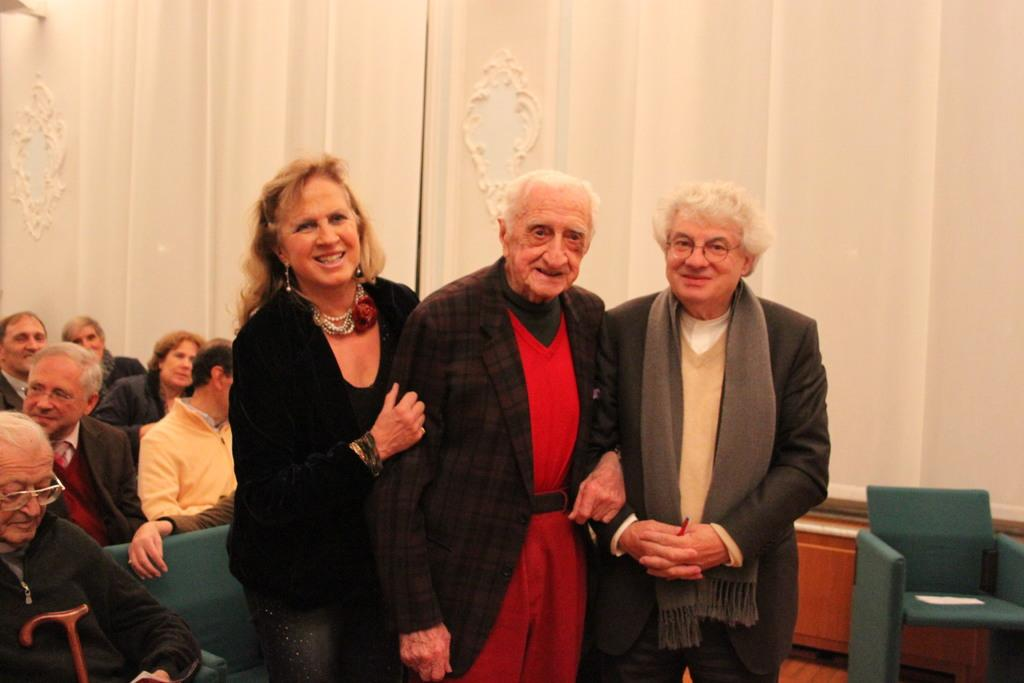How many people are in the image? There is a group of people in the image. What are the people in the image doing? Some people are seated, while others are standing. What can be seen in the background of the image? There is a wall and a light in the background of the image. What are the hobbies of the dad in the image? There is no dad or specific individuals mentioned in the image, so it is not possible to determine their hobbies. 